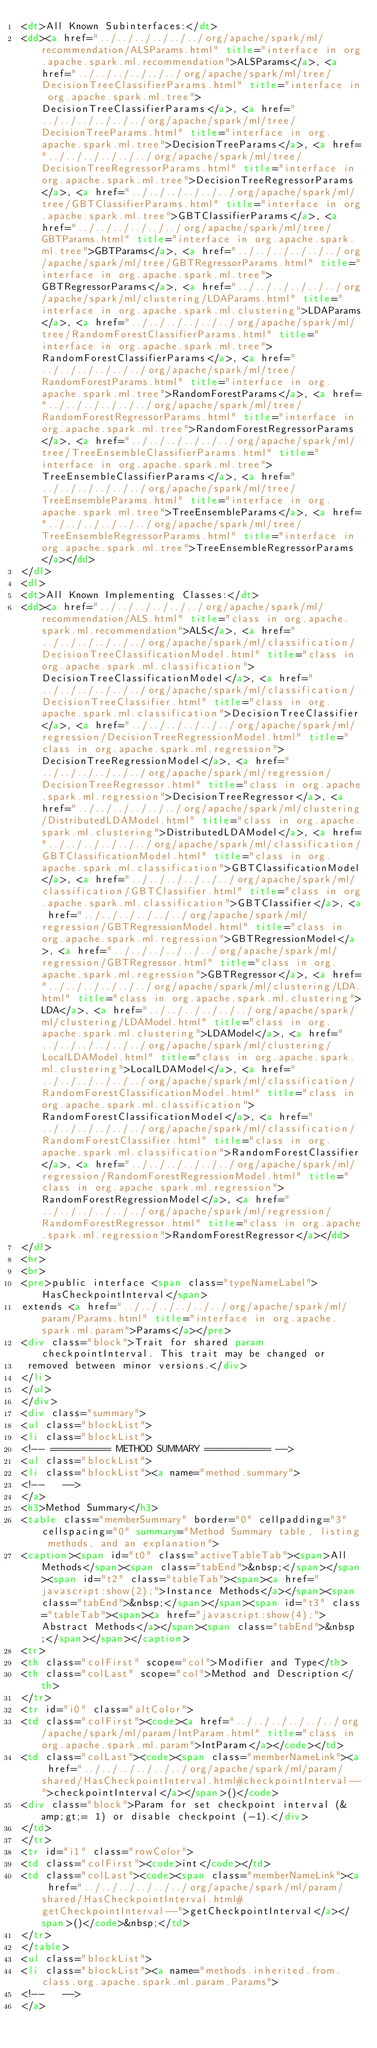<code> <loc_0><loc_0><loc_500><loc_500><_HTML_><dt>All Known Subinterfaces:</dt>
<dd><a href="../../../../../../org/apache/spark/ml/recommendation/ALSParams.html" title="interface in org.apache.spark.ml.recommendation">ALSParams</a>, <a href="../../../../../../org/apache/spark/ml/tree/DecisionTreeClassifierParams.html" title="interface in org.apache.spark.ml.tree">DecisionTreeClassifierParams</a>, <a href="../../../../../../org/apache/spark/ml/tree/DecisionTreeParams.html" title="interface in org.apache.spark.ml.tree">DecisionTreeParams</a>, <a href="../../../../../../org/apache/spark/ml/tree/DecisionTreeRegressorParams.html" title="interface in org.apache.spark.ml.tree">DecisionTreeRegressorParams</a>, <a href="../../../../../../org/apache/spark/ml/tree/GBTClassifierParams.html" title="interface in org.apache.spark.ml.tree">GBTClassifierParams</a>, <a href="../../../../../../org/apache/spark/ml/tree/GBTParams.html" title="interface in org.apache.spark.ml.tree">GBTParams</a>, <a href="../../../../../../org/apache/spark/ml/tree/GBTRegressorParams.html" title="interface in org.apache.spark.ml.tree">GBTRegressorParams</a>, <a href="../../../../../../org/apache/spark/ml/clustering/LDAParams.html" title="interface in org.apache.spark.ml.clustering">LDAParams</a>, <a href="../../../../../../org/apache/spark/ml/tree/RandomForestClassifierParams.html" title="interface in org.apache.spark.ml.tree">RandomForestClassifierParams</a>, <a href="../../../../../../org/apache/spark/ml/tree/RandomForestParams.html" title="interface in org.apache.spark.ml.tree">RandomForestParams</a>, <a href="../../../../../../org/apache/spark/ml/tree/RandomForestRegressorParams.html" title="interface in org.apache.spark.ml.tree">RandomForestRegressorParams</a>, <a href="../../../../../../org/apache/spark/ml/tree/TreeEnsembleClassifierParams.html" title="interface in org.apache.spark.ml.tree">TreeEnsembleClassifierParams</a>, <a href="../../../../../../org/apache/spark/ml/tree/TreeEnsembleParams.html" title="interface in org.apache.spark.ml.tree">TreeEnsembleParams</a>, <a href="../../../../../../org/apache/spark/ml/tree/TreeEnsembleRegressorParams.html" title="interface in org.apache.spark.ml.tree">TreeEnsembleRegressorParams</a></dd>
</dl>
<dl>
<dt>All Known Implementing Classes:</dt>
<dd><a href="../../../../../../org/apache/spark/ml/recommendation/ALS.html" title="class in org.apache.spark.ml.recommendation">ALS</a>, <a href="../../../../../../org/apache/spark/ml/classification/DecisionTreeClassificationModel.html" title="class in org.apache.spark.ml.classification">DecisionTreeClassificationModel</a>, <a href="../../../../../../org/apache/spark/ml/classification/DecisionTreeClassifier.html" title="class in org.apache.spark.ml.classification">DecisionTreeClassifier</a>, <a href="../../../../../../org/apache/spark/ml/regression/DecisionTreeRegressionModel.html" title="class in org.apache.spark.ml.regression">DecisionTreeRegressionModel</a>, <a href="../../../../../../org/apache/spark/ml/regression/DecisionTreeRegressor.html" title="class in org.apache.spark.ml.regression">DecisionTreeRegressor</a>, <a href="../../../../../../org/apache/spark/ml/clustering/DistributedLDAModel.html" title="class in org.apache.spark.ml.clustering">DistributedLDAModel</a>, <a href="../../../../../../org/apache/spark/ml/classification/GBTClassificationModel.html" title="class in org.apache.spark.ml.classification">GBTClassificationModel</a>, <a href="../../../../../../org/apache/spark/ml/classification/GBTClassifier.html" title="class in org.apache.spark.ml.classification">GBTClassifier</a>, <a href="../../../../../../org/apache/spark/ml/regression/GBTRegressionModel.html" title="class in org.apache.spark.ml.regression">GBTRegressionModel</a>, <a href="../../../../../../org/apache/spark/ml/regression/GBTRegressor.html" title="class in org.apache.spark.ml.regression">GBTRegressor</a>, <a href="../../../../../../org/apache/spark/ml/clustering/LDA.html" title="class in org.apache.spark.ml.clustering">LDA</a>, <a href="../../../../../../org/apache/spark/ml/clustering/LDAModel.html" title="class in org.apache.spark.ml.clustering">LDAModel</a>, <a href="../../../../../../org/apache/spark/ml/clustering/LocalLDAModel.html" title="class in org.apache.spark.ml.clustering">LocalLDAModel</a>, <a href="../../../../../../org/apache/spark/ml/classification/RandomForestClassificationModel.html" title="class in org.apache.spark.ml.classification">RandomForestClassificationModel</a>, <a href="../../../../../../org/apache/spark/ml/classification/RandomForestClassifier.html" title="class in org.apache.spark.ml.classification">RandomForestClassifier</a>, <a href="../../../../../../org/apache/spark/ml/regression/RandomForestRegressionModel.html" title="class in org.apache.spark.ml.regression">RandomForestRegressionModel</a>, <a href="../../../../../../org/apache/spark/ml/regression/RandomForestRegressor.html" title="class in org.apache.spark.ml.regression">RandomForestRegressor</a></dd>
</dl>
<hr>
<br>
<pre>public interface <span class="typeNameLabel">HasCheckpointInterval</span>
extends <a href="../../../../../../org/apache/spark/ml/param/Params.html" title="interface in org.apache.spark.ml.param">Params</a></pre>
<div class="block">Trait for shared param checkpointInterval. This trait may be changed or
 removed between minor versions.</div>
</li>
</ul>
</div>
<div class="summary">
<ul class="blockList">
<li class="blockList">
<!-- ========== METHOD SUMMARY =========== -->
<ul class="blockList">
<li class="blockList"><a name="method.summary">
<!--   -->
</a>
<h3>Method Summary</h3>
<table class="memberSummary" border="0" cellpadding="3" cellspacing="0" summary="Method Summary table, listing methods, and an explanation">
<caption><span id="t0" class="activeTableTab"><span>All Methods</span><span class="tabEnd">&nbsp;</span></span><span id="t2" class="tableTab"><span><a href="javascript:show(2);">Instance Methods</a></span><span class="tabEnd">&nbsp;</span></span><span id="t3" class="tableTab"><span><a href="javascript:show(4);">Abstract Methods</a></span><span class="tabEnd">&nbsp;</span></span></caption>
<tr>
<th class="colFirst" scope="col">Modifier and Type</th>
<th class="colLast" scope="col">Method and Description</th>
</tr>
<tr id="i0" class="altColor">
<td class="colFirst"><code><a href="../../../../../../org/apache/spark/ml/param/IntParam.html" title="class in org.apache.spark.ml.param">IntParam</a></code></td>
<td class="colLast"><code><span class="memberNameLink"><a href="../../../../../../org/apache/spark/ml/param/shared/HasCheckpointInterval.html#checkpointInterval--">checkpointInterval</a></span>()</code>
<div class="block">Param for set checkpoint interval (&amp;gt;= 1) or disable checkpoint (-1).</div>
</td>
</tr>
<tr id="i1" class="rowColor">
<td class="colFirst"><code>int</code></td>
<td class="colLast"><code><span class="memberNameLink"><a href="../../../../../../org/apache/spark/ml/param/shared/HasCheckpointInterval.html#getCheckpointInterval--">getCheckpointInterval</a></span>()</code>&nbsp;</td>
</tr>
</table>
<ul class="blockList">
<li class="blockList"><a name="methods.inherited.from.class.org.apache.spark.ml.param.Params">
<!--   -->
</a></code> 